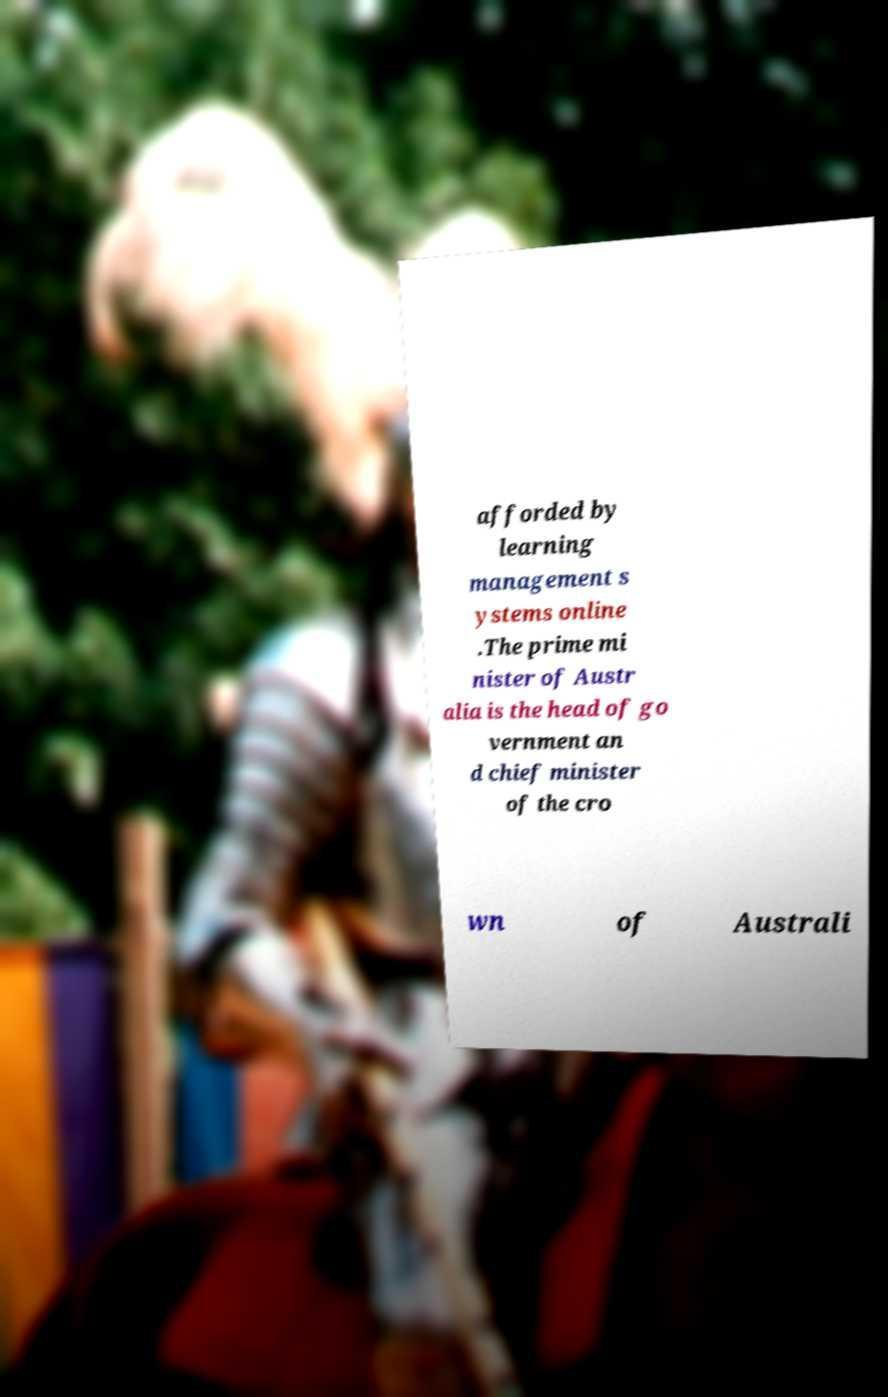Could you extract and type out the text from this image? afforded by learning management s ystems online .The prime mi nister of Austr alia is the head of go vernment an d chief minister of the cro wn of Australi 